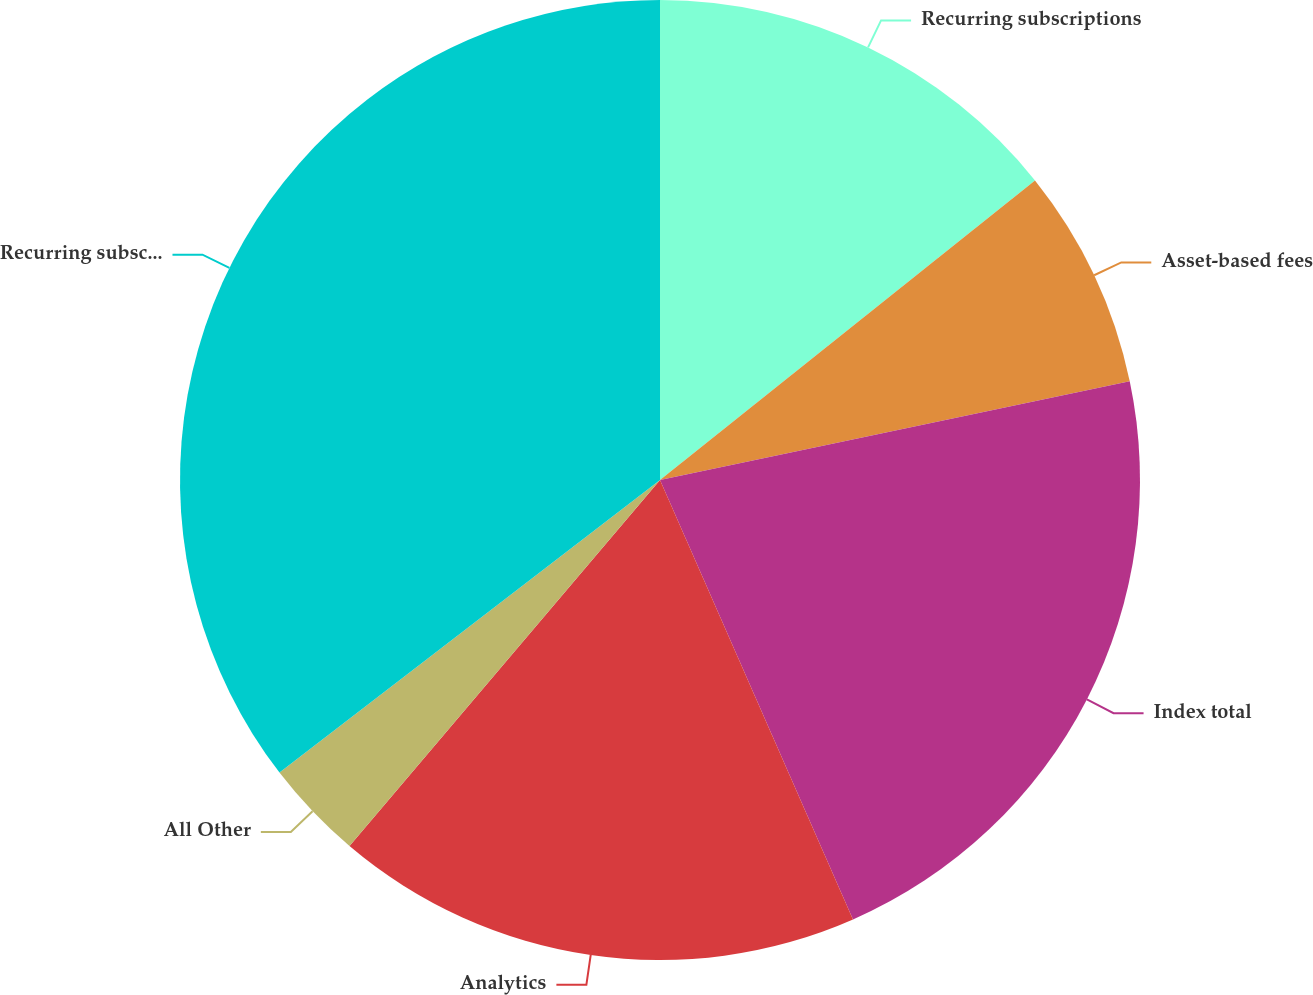<chart> <loc_0><loc_0><loc_500><loc_500><pie_chart><fcel>Recurring subscriptions<fcel>Asset-based fees<fcel>Index total<fcel>Analytics<fcel>All Other<fcel>Recurring subscriptions total<nl><fcel>14.27%<fcel>7.43%<fcel>21.71%<fcel>17.78%<fcel>3.37%<fcel>35.43%<nl></chart> 